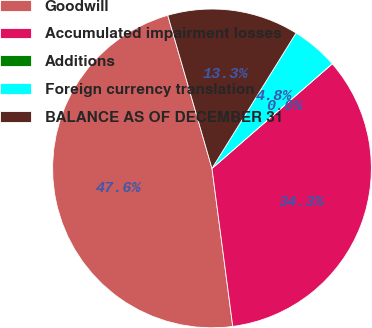<chart> <loc_0><loc_0><loc_500><loc_500><pie_chart><fcel>Goodwill<fcel>Accumulated impairment losses<fcel>Additions<fcel>Foreign currency translation<fcel>BALANCE AS OF DECEMBER 31<nl><fcel>47.6%<fcel>34.31%<fcel>0.0%<fcel>4.76%<fcel>13.32%<nl></chart> 